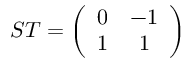<formula> <loc_0><loc_0><loc_500><loc_500>S T = \left ( \begin{array} { c c } { 0 } & { - 1 } \\ { 1 } & { 1 } \end{array} \right )</formula> 